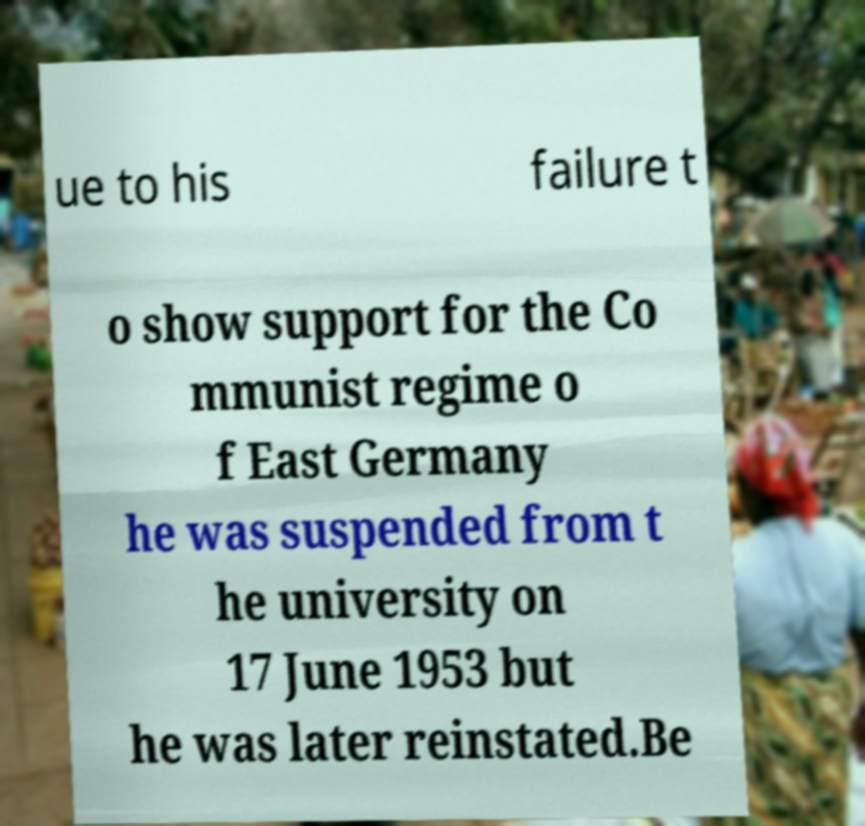What messages or text are displayed in this image? I need them in a readable, typed format. ue to his failure t o show support for the Co mmunist regime o f East Germany he was suspended from t he university on 17 June 1953 but he was later reinstated.Be 